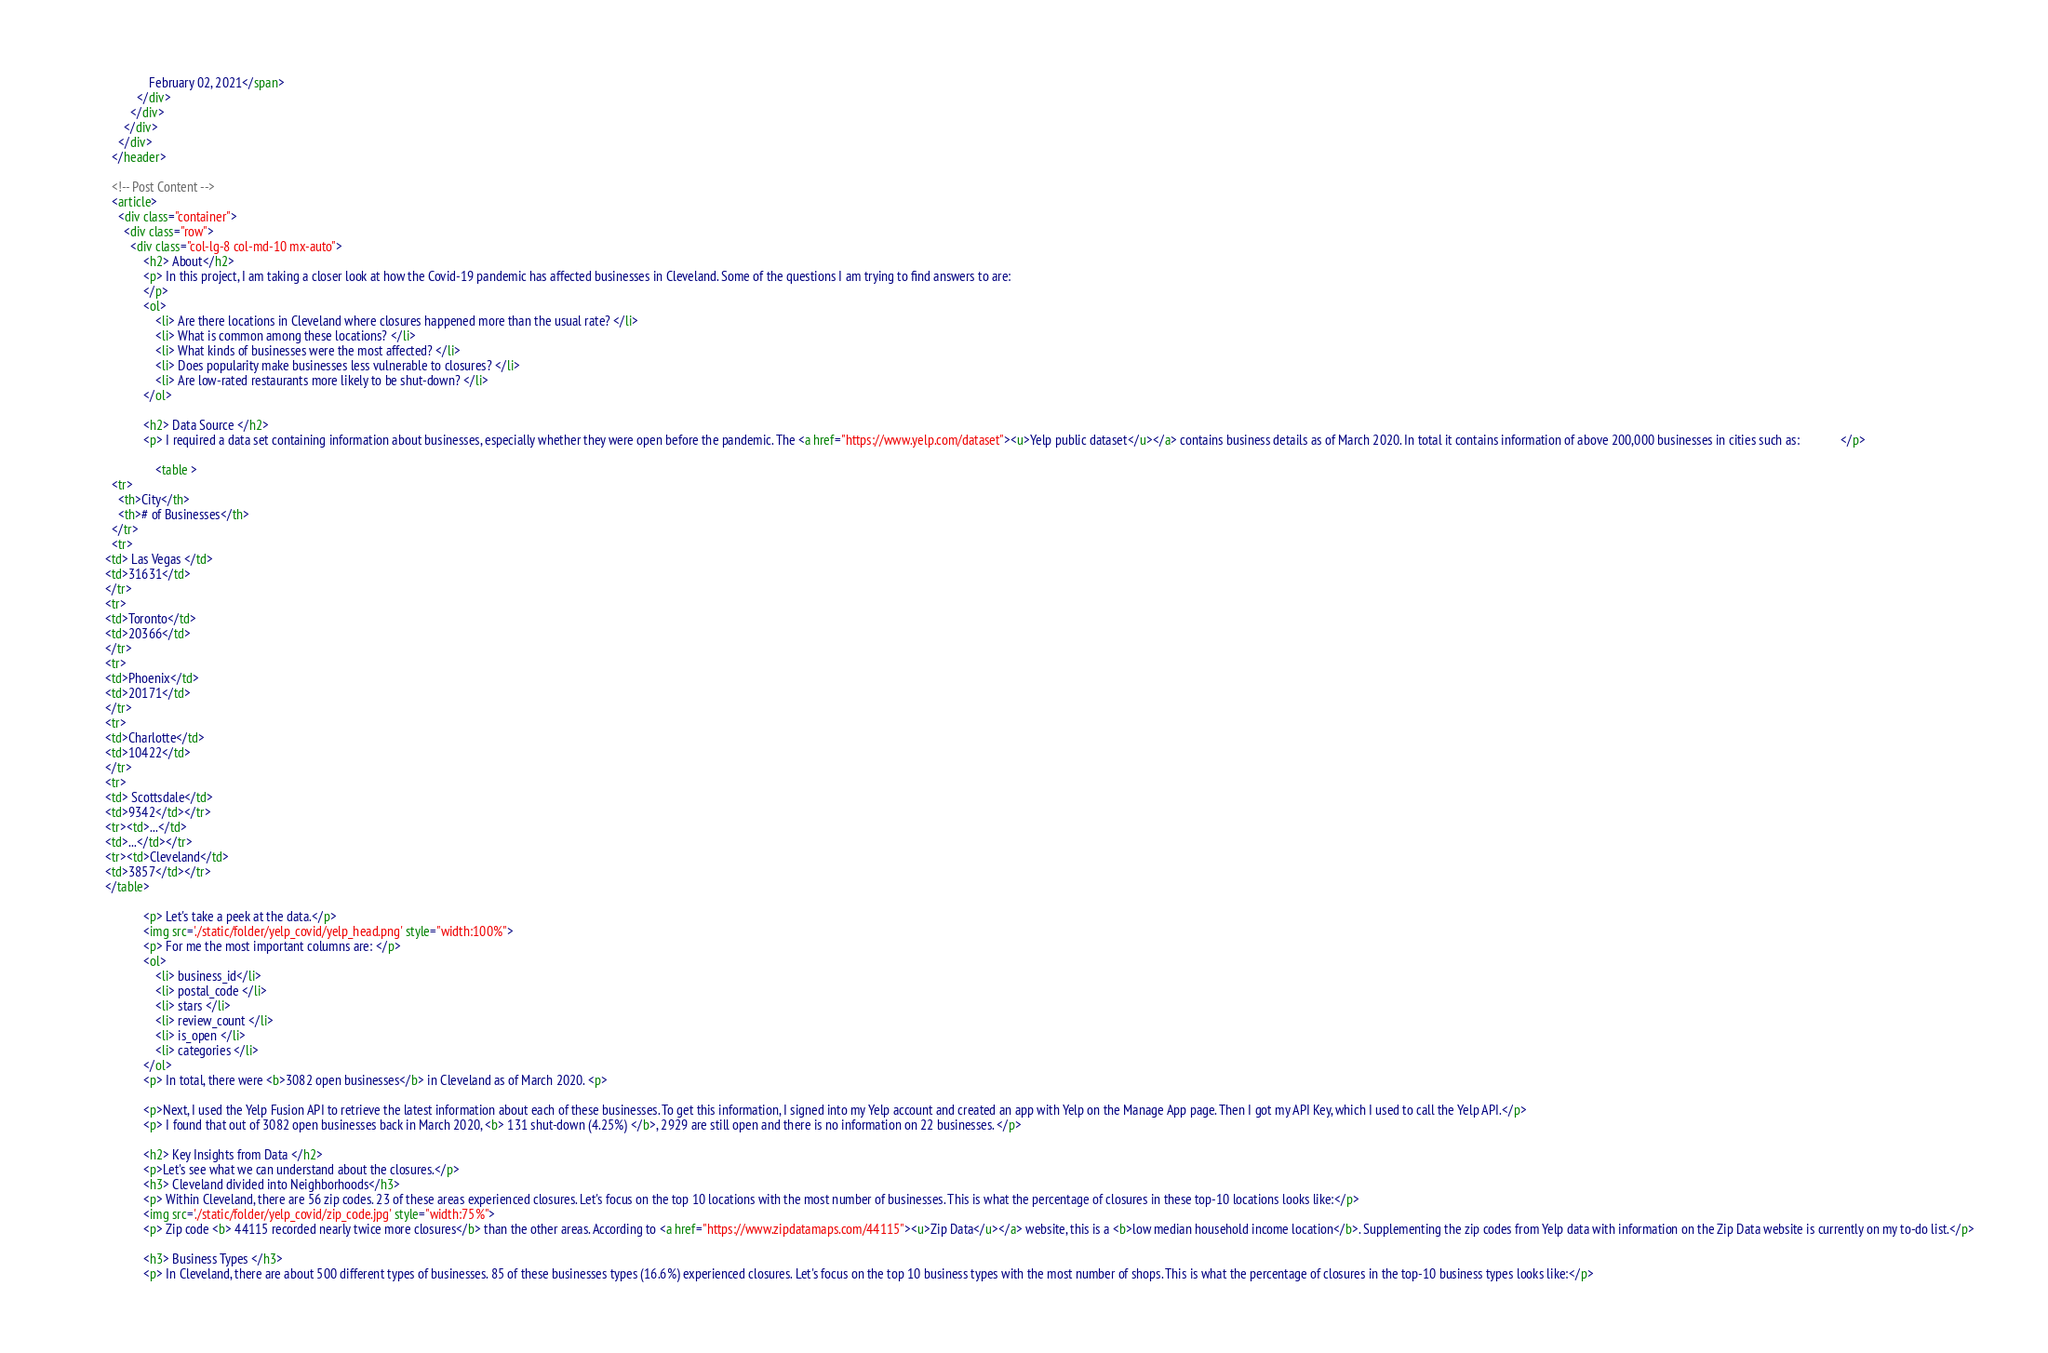Convert code to text. <code><loc_0><loc_0><loc_500><loc_500><_HTML_>              February 02, 2021</span>
          </div>
        </div>
      </div>
    </div>
  </header>

  <!-- Post Content -->
  <article>
    <div class="container">
      <div class="row">
        <div class="col-lg-8 col-md-10 mx-auto">
            <h2> About</h2>
            <p> In this project, I am taking a closer look at how the Covid-19 pandemic has affected businesses in Cleveland. Some of the questions I am trying to find answers to are:
            </p>
            <ol> 
                <li> Are there locations in Cleveland where closures happened more than the usual rate? </li>
                <li> What is common among these locations? </li>
                <li> What kinds of businesses were the most affected? </li>
                <li> Does popularity make businesses less vulnerable to closures? </li>
                <li> Are low-rated restaurants more likely to be shut-down? </li>
            </ol>
            
            <h2> Data Source </h2>
            <p> I required a data set containing information about businesses, especially whether they were open before the pandemic. The <a href="https://www.yelp.com/dataset"><u>Yelp public dataset</u></a> contains business details as of March 2020. In total it contains information of above 200,000 businesses in cities such as:             </p>

                <table >
  <tr>
    <th>City</th>
    <th># of Businesses</th>
  </tr>
  <tr>
<td> Las Vegas </td>
<td>31631</td>
</tr>
<tr>    
<td>Toronto</td>
<td>20366</td>
</tr>
<tr>    
<td>Phoenix</td>
<td>20171</td>
</tr>
<tr>    
<td>Charlotte</td>
<td>10422</td>
</tr>
<tr>    
<td> Scottsdale</td>
<td>9342</td></tr>
<tr><td>...</td>
<td>...</td></tr>
<tr><td>Cleveland</td>
<td>3857</td></tr>
</table> 
            
            <p> Let's take a peek at the data.</p>    
            <img src='./static/folder/yelp_covid/yelp_head.png' style="width:100%">
            <p> For me the most important columns are: </p>
            <ol> 
                <li> business_id</li>
                <li> postal_code </li>
                <li> stars </li>
                <li> review_count </li>
                <li> is_open </li>
                <li> categories </li>
            </ol>
            <p> In total, there were <b>3082 open businesses</b> in Cleveland as of March 2020. <p>
            
            <p>Next, I used the Yelp Fusion API to retrieve the latest information about each of these businesses. To get this information, I signed into my Yelp account and created an app with Yelp on the Manage App page. Then I got my API Key, which I used to call the Yelp API.</p>  
            <p> I found that out of 3082 open businesses back in March 2020, <b> 131 shut-down (4.25%) </b>, 2929 are still open and there is no information on 22 businesses. </p>
            
            <h2> Key Insights from Data </h2>
            <p>Let's see what we can understand about the closures.</p>
            <h3> Cleveland divided into Neighborhoods</h3>
            <p> Within Cleveland, there are 56 zip codes. 23 of these areas experienced closures. Let's focus on the top 10 locations with the most number of businesses. This is what the percentage of closures in these top-10 locations looks like:</p>
            <img src='./static/folder/yelp_covid/zip_code.jpg' style="width:75%">
            <p> Zip code <b> 44115 recorded nearly twice more closures</b> than the other areas. According to <a href="https://www.zipdatamaps.com/44115"><u>Zip Data</u></a> website, this is a <b>low median household income location</b>. Supplementing the zip codes from Yelp data with information on the Zip Data website is currently on my to-do list.</p>
            
            <h3> Business Types </h3>
            <p> In Cleveland, there are about 500 different types of businesses. 85 of these businesses types (16.6%) experienced closures. Let's focus on the top 10 business types with the most number of shops. This is what the percentage of closures in the top-10 business types looks like:</p></code> 